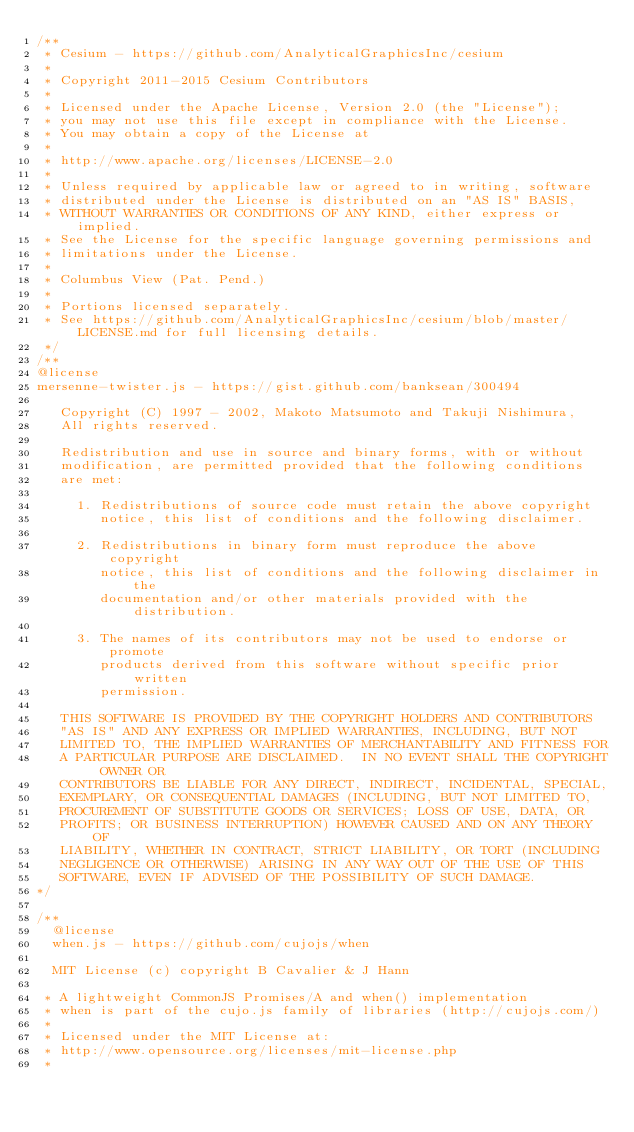Convert code to text. <code><loc_0><loc_0><loc_500><loc_500><_JavaScript_>/**
 * Cesium - https://github.com/AnalyticalGraphicsInc/cesium
 *
 * Copyright 2011-2015 Cesium Contributors
 *
 * Licensed under the Apache License, Version 2.0 (the "License");
 * you may not use this file except in compliance with the License.
 * You may obtain a copy of the License at
 *
 * http://www.apache.org/licenses/LICENSE-2.0
 *
 * Unless required by applicable law or agreed to in writing, software
 * distributed under the License is distributed on an "AS IS" BASIS,
 * WITHOUT WARRANTIES OR CONDITIONS OF ANY KIND, either express or implied.
 * See the License for the specific language governing permissions and
 * limitations under the License.
 *
 * Columbus View (Pat. Pend.)
 *
 * Portions licensed separately.
 * See https://github.com/AnalyticalGraphicsInc/cesium/blob/master/LICENSE.md for full licensing details.
 */
/**
@license
mersenne-twister.js - https://gist.github.com/banksean/300494

   Copyright (C) 1997 - 2002, Makoto Matsumoto and Takuji Nishimura,
   All rights reserved.

   Redistribution and use in source and binary forms, with or without
   modification, are permitted provided that the following conditions
   are met:

     1. Redistributions of source code must retain the above copyright
        notice, this list of conditions and the following disclaimer.

     2. Redistributions in binary form must reproduce the above copyright
        notice, this list of conditions and the following disclaimer in the
        documentation and/or other materials provided with the distribution.

     3. The names of its contributors may not be used to endorse or promote
        products derived from this software without specific prior written
        permission.

   THIS SOFTWARE IS PROVIDED BY THE COPYRIGHT HOLDERS AND CONTRIBUTORS
   "AS IS" AND ANY EXPRESS OR IMPLIED WARRANTIES, INCLUDING, BUT NOT
   LIMITED TO, THE IMPLIED WARRANTIES OF MERCHANTABILITY AND FITNESS FOR
   A PARTICULAR PURPOSE ARE DISCLAIMED.  IN NO EVENT SHALL THE COPYRIGHT OWNER OR
   CONTRIBUTORS BE LIABLE FOR ANY DIRECT, INDIRECT, INCIDENTAL, SPECIAL,
   EXEMPLARY, OR CONSEQUENTIAL DAMAGES (INCLUDING, BUT NOT LIMITED TO,
   PROCUREMENT OF SUBSTITUTE GOODS OR SERVICES; LOSS OF USE, DATA, OR
   PROFITS; OR BUSINESS INTERRUPTION) HOWEVER CAUSED AND ON ANY THEORY OF
   LIABILITY, WHETHER IN CONTRACT, STRICT LIABILITY, OR TORT (INCLUDING
   NEGLIGENCE OR OTHERWISE) ARISING IN ANY WAY OUT OF THE USE OF THIS
   SOFTWARE, EVEN IF ADVISED OF THE POSSIBILITY OF SUCH DAMAGE.
*/

/**
  @license
  when.js - https://github.com/cujojs/when

  MIT License (c) copyright B Cavalier & J Hann

 * A lightweight CommonJS Promises/A and when() implementation
 * when is part of the cujo.js family of libraries (http://cujojs.com/)
 *
 * Licensed under the MIT License at:
 * http://www.opensource.org/licenses/mit-license.php
 *</code> 